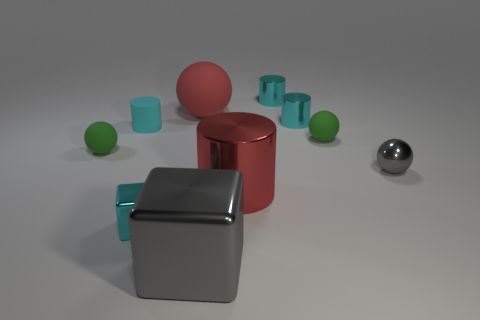Subtract all gray spheres. How many cyan cylinders are left? 3 Subtract all big spheres. How many spheres are left? 3 Subtract 2 cylinders. How many cylinders are left? 2 Subtract all cyan balls. Subtract all yellow cylinders. How many balls are left? 4 Subtract all cubes. How many objects are left? 8 Add 2 red rubber things. How many red rubber things exist? 3 Subtract 0 blue cylinders. How many objects are left? 10 Subtract all red shiny things. Subtract all small shiny spheres. How many objects are left? 8 Add 7 cyan metal things. How many cyan metal things are left? 10 